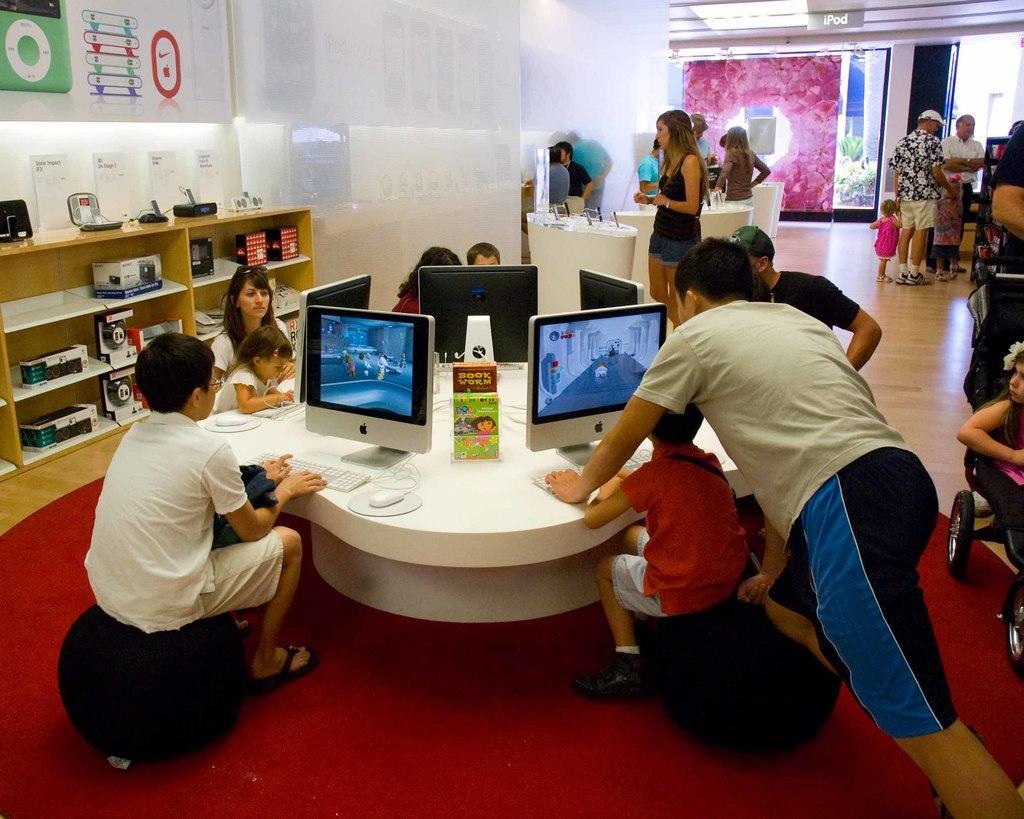In one or two sentences, can you explain what this image depicts? In this picture we can see many kids and people sitting on chairs near a round table with many computer systems on it. In the background, we can see many people standing. 